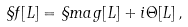<formula> <loc_0><loc_0><loc_500><loc_500>\S f [ L ] = \S m a g [ L ] + i \Theta [ L ] \, ,</formula> 